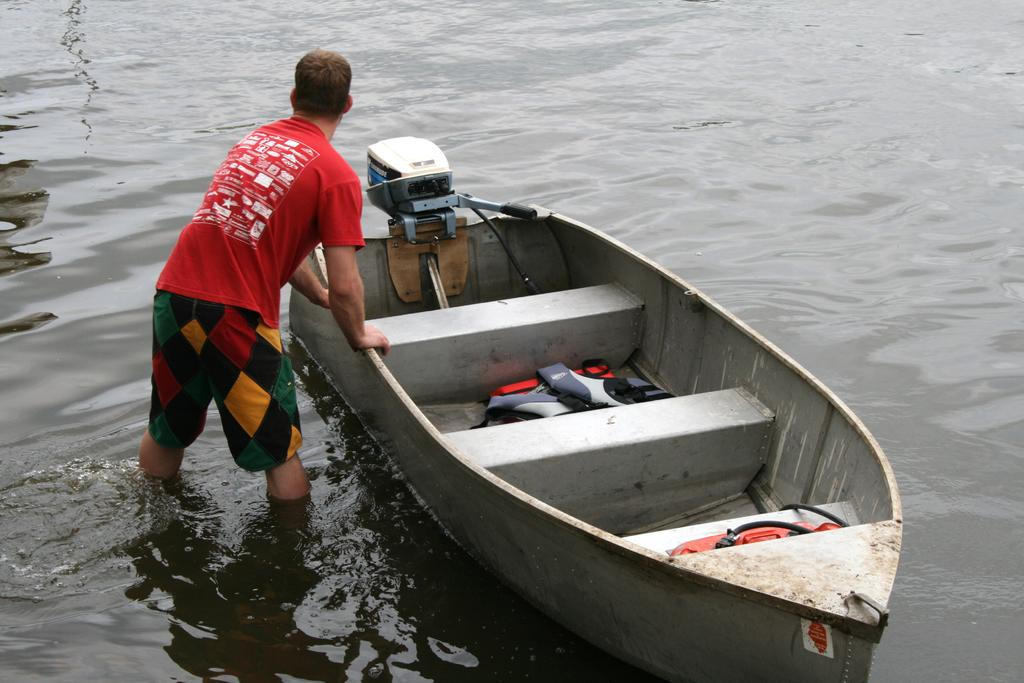What is the main subject of the image? There is a person standing in the image. Can you describe the person's attire? The person is wearing clothes. What can be seen in the water in the image? There is a boat in the water. What safety equipment is present in the boat? Life jackets are present in the boat. How does the person celebrate their birthday in the image? There is no indication of a birthday celebration in the image. What type of growth can be observed in the alley behind the person? There is no alley present in the image, so growth cannot be observed in that context. 